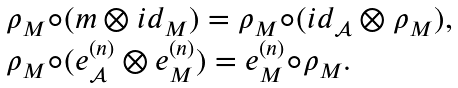<formula> <loc_0><loc_0><loc_500><loc_500>\begin{array} { l } \rho _ { M } \circ ( m \otimes i d _ { M } ) = \rho _ { M } \circ ( i d _ { \mathcal { A } } \otimes \rho _ { M } ) , \\ \rho _ { M } \circ ( e ^ { ( n ) } _ { \mathcal { A } } \otimes e ^ { ( n ) } _ { M } ) = e ^ { ( n ) } _ { M } \circ \rho _ { M } . \end{array}</formula> 